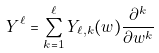Convert formula to latex. <formula><loc_0><loc_0><loc_500><loc_500>Y ^ { \ell } = \sum _ { k = 1 } ^ { \ell } Y _ { \ell , k } ( w ) \frac { \partial ^ { k } } { \partial w ^ { k } }</formula> 